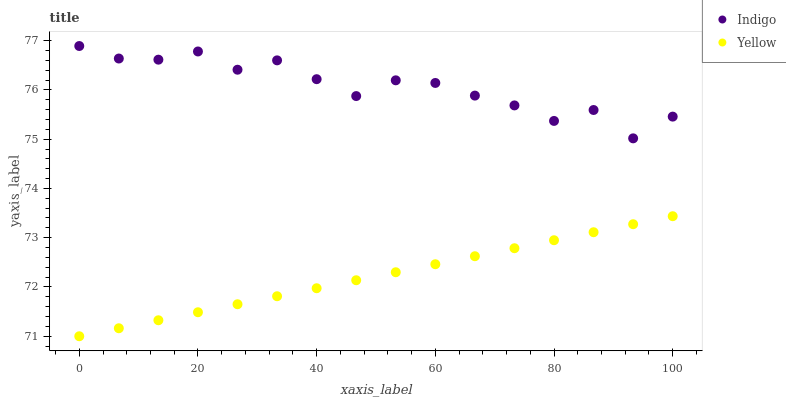Does Yellow have the minimum area under the curve?
Answer yes or no. Yes. Does Indigo have the maximum area under the curve?
Answer yes or no. Yes. Does Yellow have the maximum area under the curve?
Answer yes or no. No. Is Yellow the smoothest?
Answer yes or no. Yes. Is Indigo the roughest?
Answer yes or no. Yes. Is Yellow the roughest?
Answer yes or no. No. Does Yellow have the lowest value?
Answer yes or no. Yes. Does Indigo have the highest value?
Answer yes or no. Yes. Does Yellow have the highest value?
Answer yes or no. No. Is Yellow less than Indigo?
Answer yes or no. Yes. Is Indigo greater than Yellow?
Answer yes or no. Yes. Does Yellow intersect Indigo?
Answer yes or no. No. 